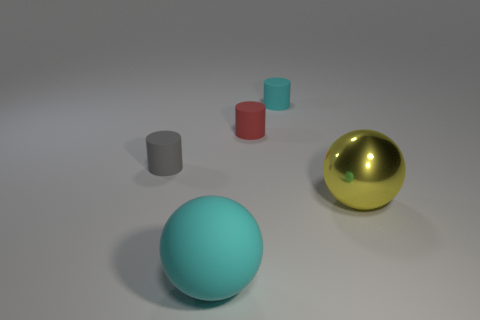Do the cyan rubber sphere and the sphere behind the large cyan rubber object have the same size?
Make the answer very short. Yes. What number of other things are there of the same shape as the red object?
Make the answer very short. 2. The other large object that is the same material as the gray object is what shape?
Offer a very short reply. Sphere. Is there a tiny red matte cylinder?
Provide a short and direct response. Yes. Is the number of metal objects that are behind the big yellow sphere less than the number of rubber objects that are behind the large cyan matte ball?
Offer a very short reply. Yes. There is a cyan matte thing that is in front of the small red rubber object; what is its shape?
Provide a short and direct response. Sphere. Do the red thing and the small gray thing have the same material?
Your response must be concise. Yes. Is there any other thing that is the same material as the big yellow thing?
Your answer should be very brief. No. What material is the yellow thing that is the same shape as the large cyan object?
Provide a succinct answer. Metal. Are there fewer tiny gray cylinders that are right of the cyan rubber cylinder than small yellow rubber things?
Keep it short and to the point. No. 